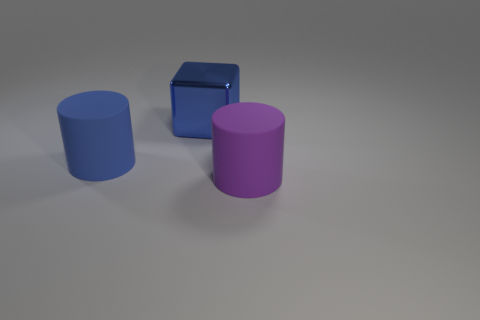There is a purple object that is the same size as the blue cylinder; what is its shape?
Offer a very short reply. Cylinder. Are there any purple balls that have the same size as the purple object?
Offer a very short reply. No. There is a purple cylinder that is the same size as the metal cube; what material is it?
Your answer should be very brief. Rubber. There is a blue thing that is on the right side of the large rubber object on the left side of the purple cylinder; what is its size?
Provide a succinct answer. Large. There is a matte thing that is left of the block; does it have the same size as the cube?
Your answer should be compact. Yes. Are there more big objects that are on the right side of the big metallic object than large purple rubber objects in front of the big purple rubber object?
Your answer should be very brief. Yes. There is a big object that is both on the left side of the big purple object and in front of the big shiny block; what shape is it?
Your answer should be very brief. Cylinder. There is a large blue object that is to the right of the large blue cylinder; what is its shape?
Ensure brevity in your answer.  Cube. There is a cylinder behind the rubber cylinder in front of the large matte thing that is behind the large purple rubber thing; what size is it?
Ensure brevity in your answer.  Large. Is the big purple matte thing the same shape as the large blue matte thing?
Provide a short and direct response. Yes. 